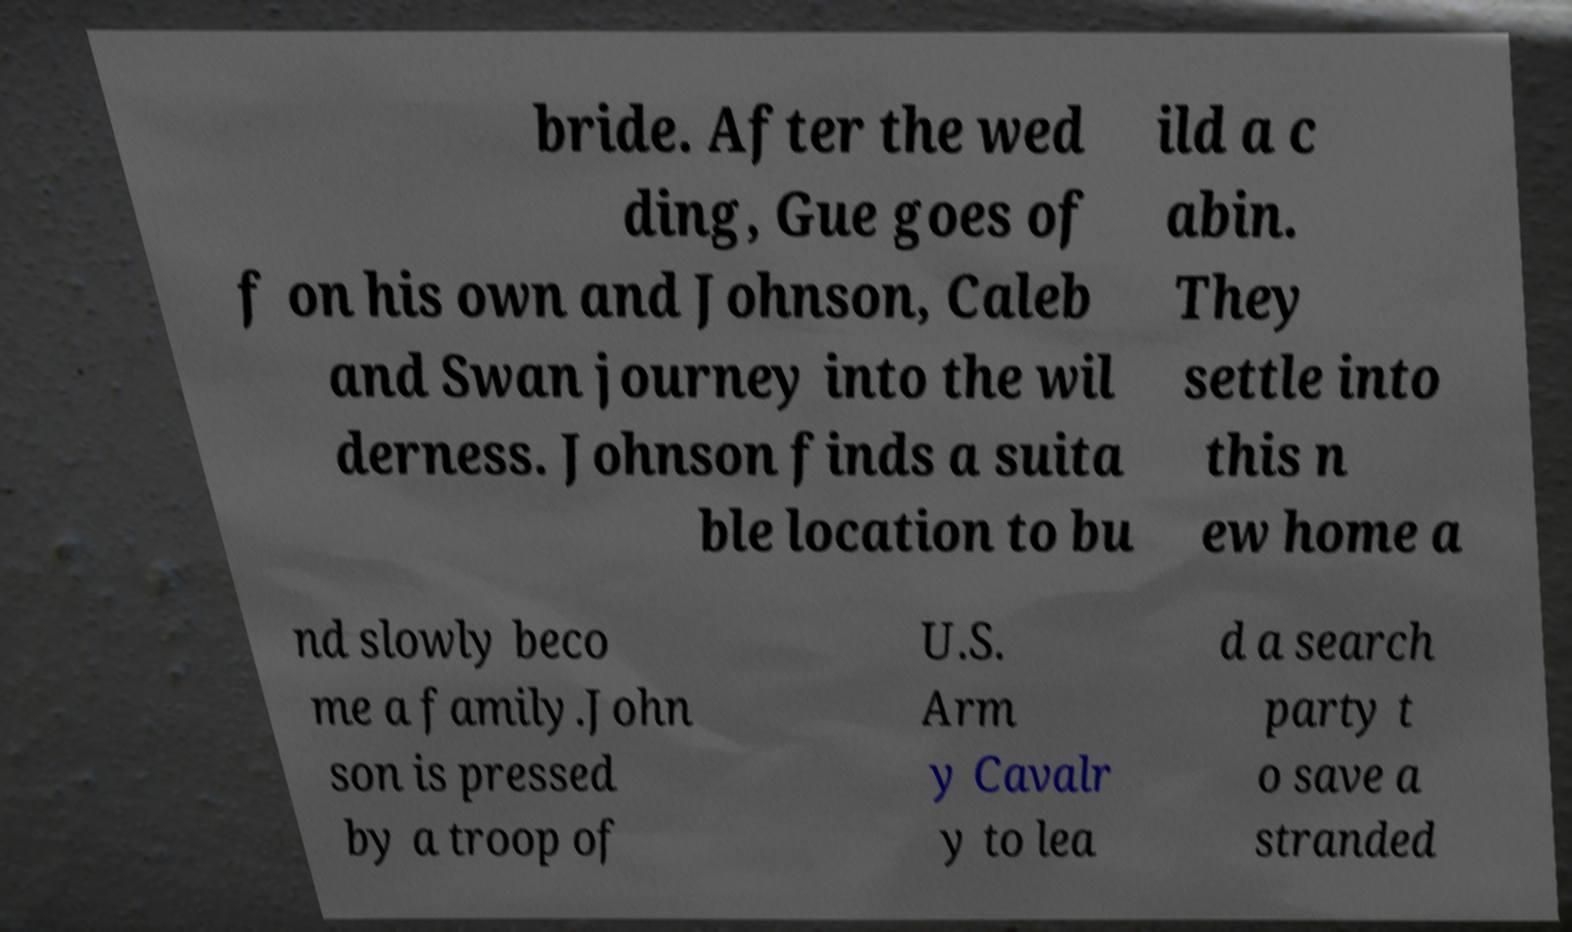For documentation purposes, I need the text within this image transcribed. Could you provide that? bride. After the wed ding, Gue goes of f on his own and Johnson, Caleb and Swan journey into the wil derness. Johnson finds a suita ble location to bu ild a c abin. They settle into this n ew home a nd slowly beco me a family.John son is pressed by a troop of U.S. Arm y Cavalr y to lea d a search party t o save a stranded 